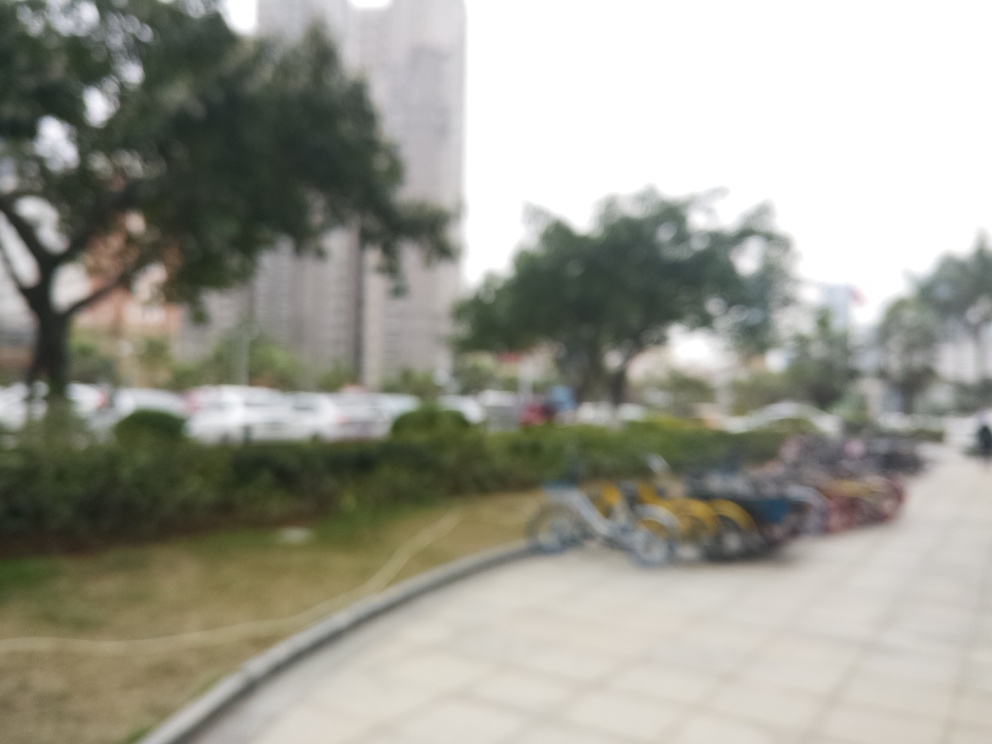What time of day does this photo appear to have been taken? The overall lighting and the absence of long shadows suggest that this photo might have been taken on an overcast day or when the sun is not at its peak, possibly in the morning or late afternoon. 